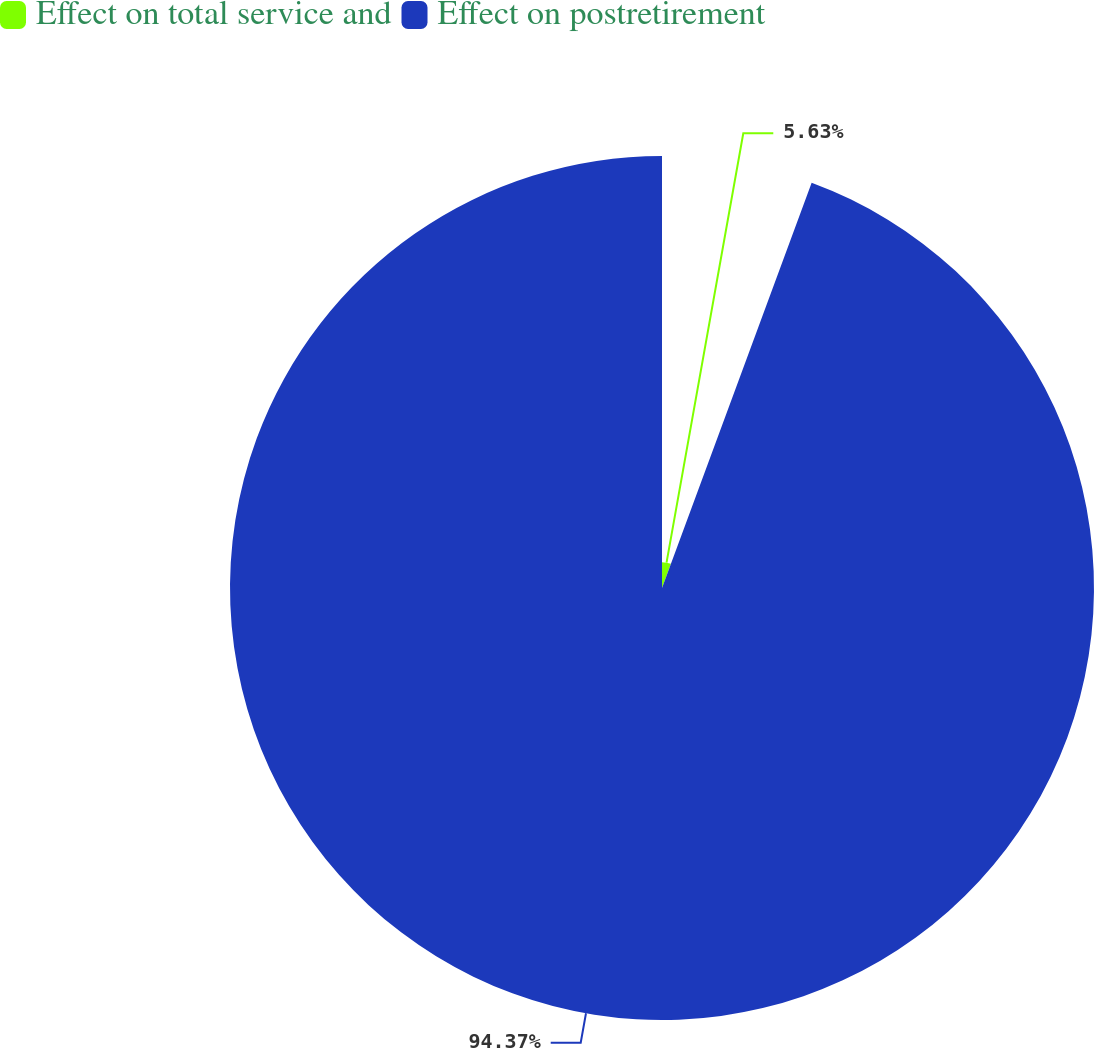Convert chart to OTSL. <chart><loc_0><loc_0><loc_500><loc_500><pie_chart><fcel>Effect on total service and<fcel>Effect on postretirement<nl><fcel>5.63%<fcel>94.37%<nl></chart> 